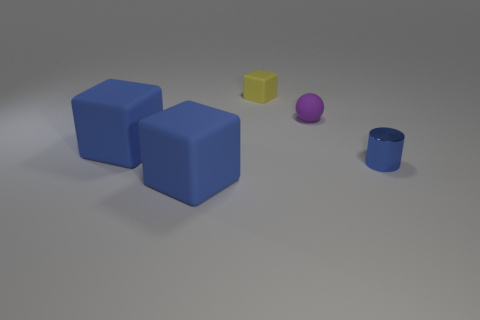Are there any blue metallic cylinders?
Your answer should be compact. Yes. Is the number of rubber things in front of the small purple rubber ball greater than the number of blocks that are in front of the small yellow block?
Your response must be concise. No. There is a yellow matte object that is on the left side of the blue thing that is to the right of the rubber block behind the purple object; how big is it?
Provide a short and direct response. Small. The tiny thing to the left of the purple object is what color?
Your answer should be compact. Yellow. Are there more small yellow things behind the blue metal cylinder than large green matte cubes?
Your response must be concise. Yes. Do the big blue object that is in front of the tiny shiny object and the tiny yellow matte thing have the same shape?
Make the answer very short. Yes. What number of purple things are spheres or cubes?
Your answer should be compact. 1. Are there more cylinders than red matte balls?
Ensure brevity in your answer.  Yes. There is a block that is the same size as the purple matte object; what color is it?
Give a very brief answer. Yellow. How many cubes are blue rubber objects or yellow objects?
Provide a succinct answer. 3. 